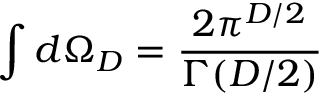Convert formula to latex. <formula><loc_0><loc_0><loc_500><loc_500>\int d \Omega _ { D } = \frac { 2 \pi ^ { D / 2 } } { \Gamma ( D / 2 ) }</formula> 